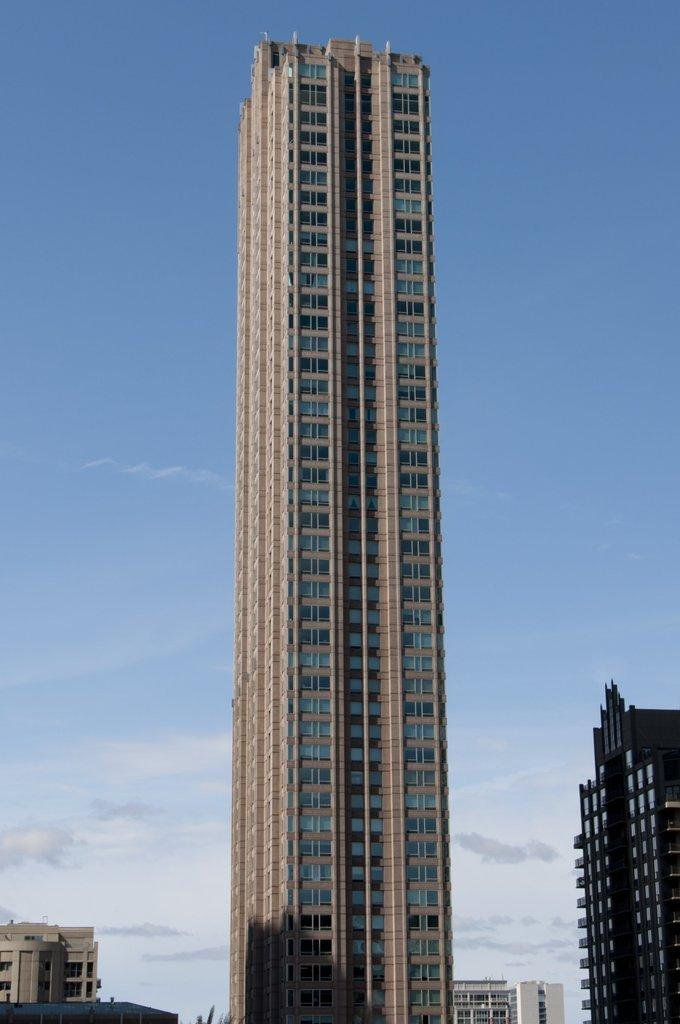What type of structures can be seen in the image? There are buildings in the image. What part of the natural environment is visible in the image? The sky is visible in the image. What can be observed in the sky? Clouds are present in the sky. What type of business is being conducted in the grassy area in the image? There is no grassy area or business activity visible in the image; it primarily features buildings and the sky. 